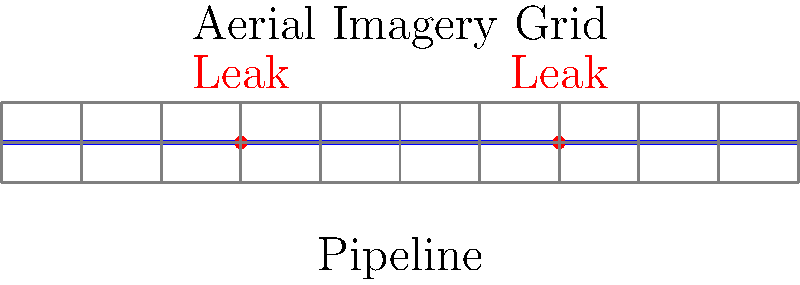In a pipeline leak detection system using aerial imagery, what is the minimum number of grid cells needed to cover both leak points if each cell has a width of 20 units? To determine the minimum number of grid cells needed to cover both leak points, we need to follow these steps:

1. Identify the positions of the leak points:
   - First leak point is at x = 30 units
   - Second leak point is at x = 70 units

2. Calculate the grid cell boundaries:
   - Each cell has a width of 20 units
   - Cell boundaries are at 0, 20, 40, 60, 80, and 100 units

3. Determine which cells contain the leak points:
   - The leak at x = 30 falls in the cell [20, 40)
   - The leak at x = 70 falls in the cell [60, 80)

4. Count the number of unique cells:
   - The leaks are in two different cells

Therefore, the minimum number of grid cells needed to cover both leak points is 2.
Answer: 2 cells 